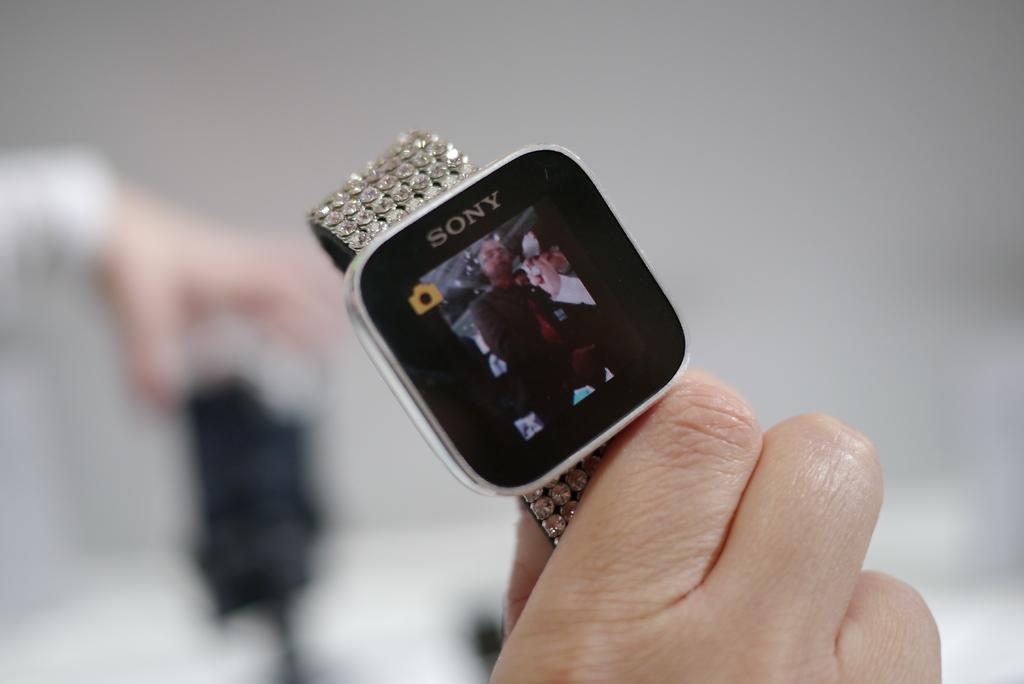Provide a one-sentence caption for the provided image. A smart watch with a giant diamond band by Sony. 